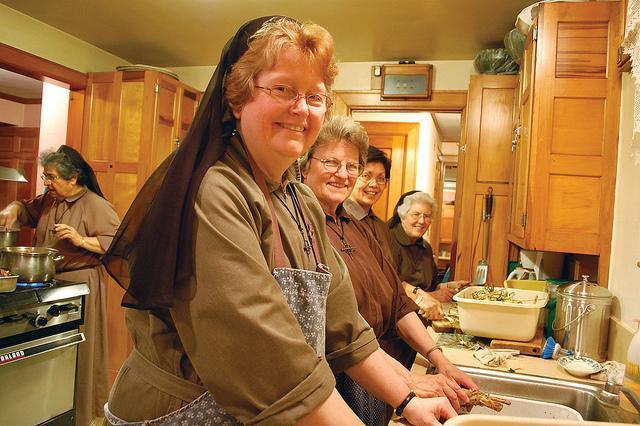How many ladies have on glasses?
Give a very brief answer. 5. How many people are there?
Give a very brief answer. 5. 